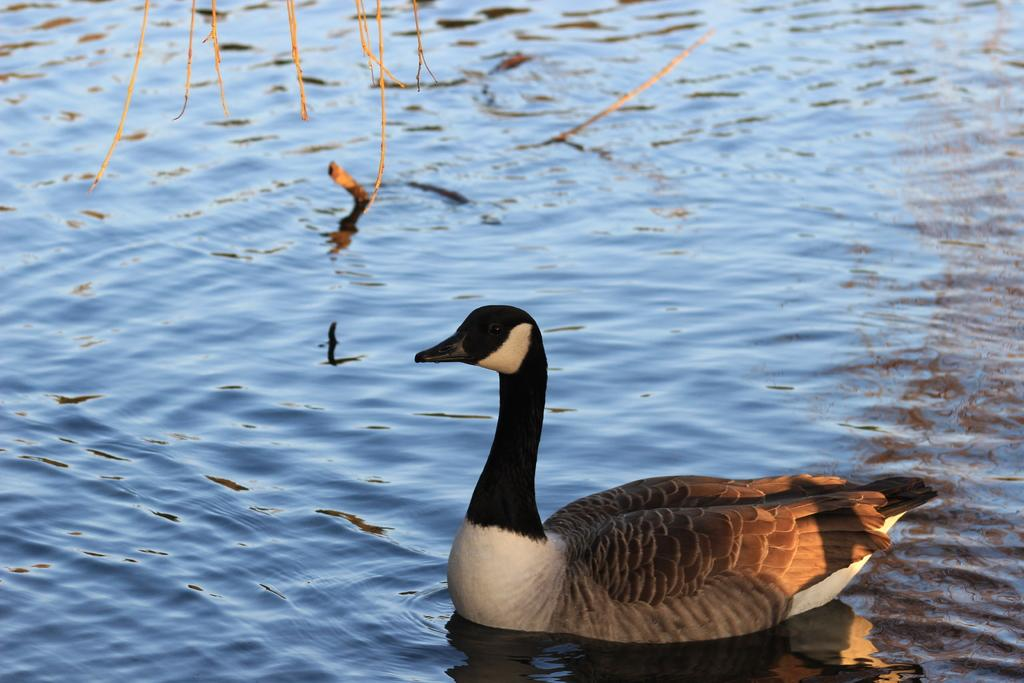What type of animal is in the image? There is a duck in the image. Where is the duck located in the image? The duck is located at the bottom right of the image. What colors can be seen on the duck? The duck has brown, white, and black coloring. What else can be seen in the image besides the duck? There are sticks visible in the image, located at the top. What type of plants does the lawyer use to make the stew in the image? There is no lawyer or stew present in the image, and therefore no such activity can be observed. 